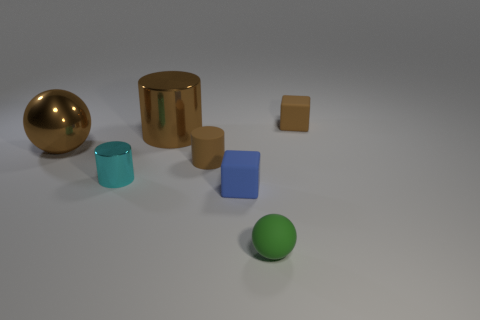Add 1 small cyan cylinders. How many objects exist? 8 Subtract all cylinders. How many objects are left? 4 Subtract all cyan objects. Subtract all large metal spheres. How many objects are left? 5 Add 7 tiny rubber balls. How many tiny rubber balls are left? 8 Add 2 big brown metal cylinders. How many big brown metal cylinders exist? 3 Subtract 0 gray balls. How many objects are left? 7 